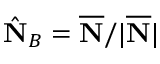<formula> <loc_0><loc_0><loc_500><loc_500>\hat { N } _ { B } = \overline { N } / | \overline { N } |</formula> 